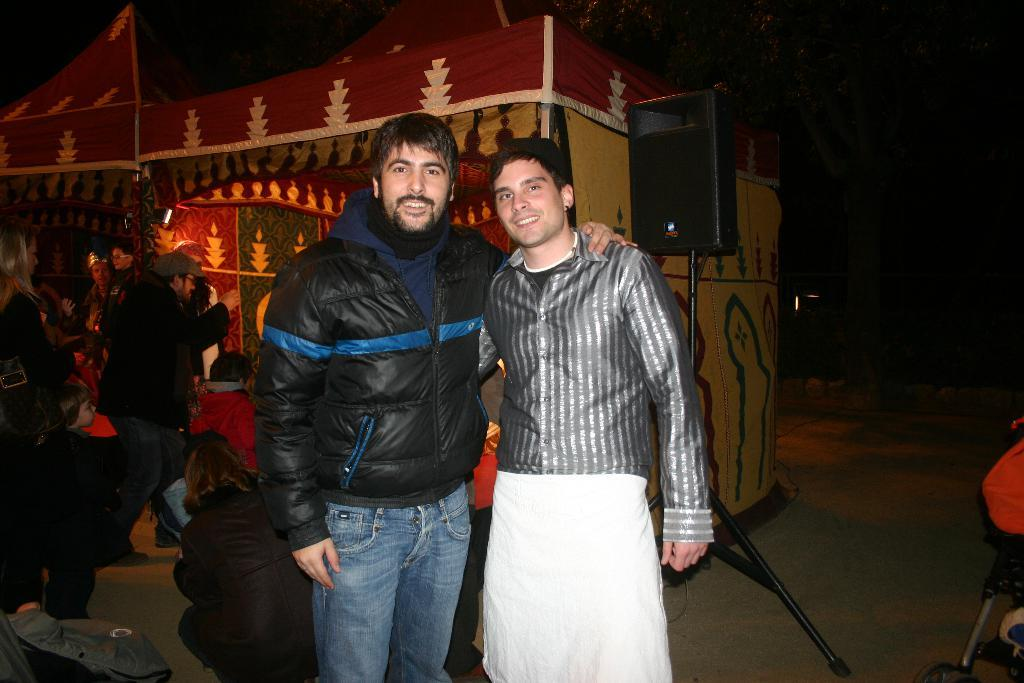How many people are in the center of the image? There are two people standing in the center of the image. What are the expressions on the faces of the two people? The two people are smiling. What can be seen in the background of the image? There is a tent, a speaker, other people, and other objects in the background of the image. What type of hat is the aunt wearing in the image? There is no aunt present in the image, and therefore no hat to describe. 